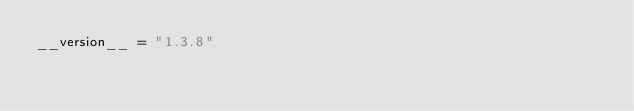Convert code to text. <code><loc_0><loc_0><loc_500><loc_500><_Python_>__version__ = "1.3.8"
</code> 